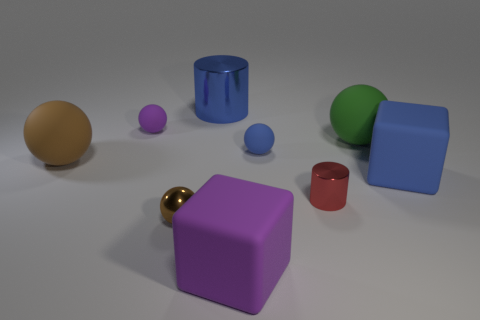Subtract all purple balls. How many balls are left? 4 Subtract all tiny brown balls. How many balls are left? 4 Subtract 2 balls. How many balls are left? 3 Subtract all red spheres. Subtract all gray cylinders. How many spheres are left? 5 Subtract all balls. How many objects are left? 4 Subtract 0 red cubes. How many objects are left? 9 Subtract all red shiny cylinders. Subtract all tiny blue matte things. How many objects are left? 7 Add 8 blocks. How many blocks are left? 10 Add 6 metallic blocks. How many metallic blocks exist? 6 